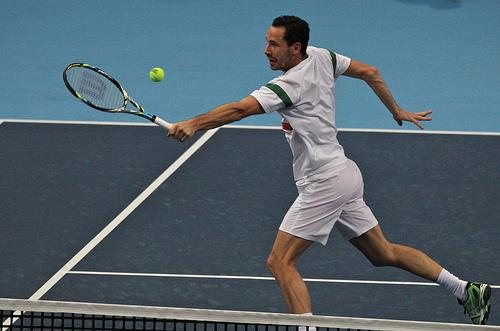Question: what sport is this man playing?
Choices:
A. Baseball.
B. Tennis.
C. Soccer.
D. Badminton.
Answer with the letter. Answer: B Question: what is this man holding?
Choices:
A. Bat.
B. Tennis Raquet.
C. Bag.
D. Ball.
Answer with the letter. Answer: B Question: what color are the man's shorts?
Choices:
A. Blue.
B. Green.
C. White.
D. Black.
Answer with the letter. Answer: C Question: what letter is on the tennis racket?
Choices:
A. M.
B. I.
C. L.
D. W.
Answer with the letter. Answer: D Question: why is this man running?
Choices:
A. Someone chasing him.
B. For exercise.
C. To hit the tennis ball.
D. To wake up.
Answer with the letter. Answer: C Question: where is the man standing?
Choices:
A. On a track.
B. On a awards platform.
C. On a tennis court.
D. On a basketball court.
Answer with the letter. Answer: C 